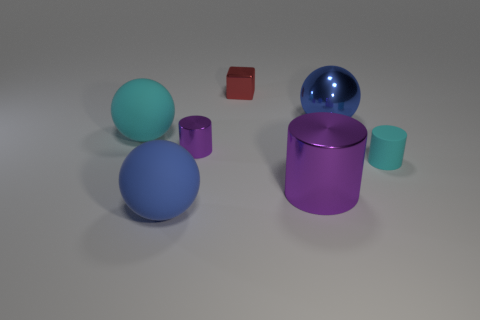Add 1 large metal spheres. How many objects exist? 8 Subtract all spheres. How many objects are left? 4 Add 7 cyan matte balls. How many cyan matte balls exist? 8 Subtract 0 gray cylinders. How many objects are left? 7 Subtract all large blue shiny things. Subtract all big purple metallic cylinders. How many objects are left? 5 Add 6 blue shiny things. How many blue shiny things are left? 7 